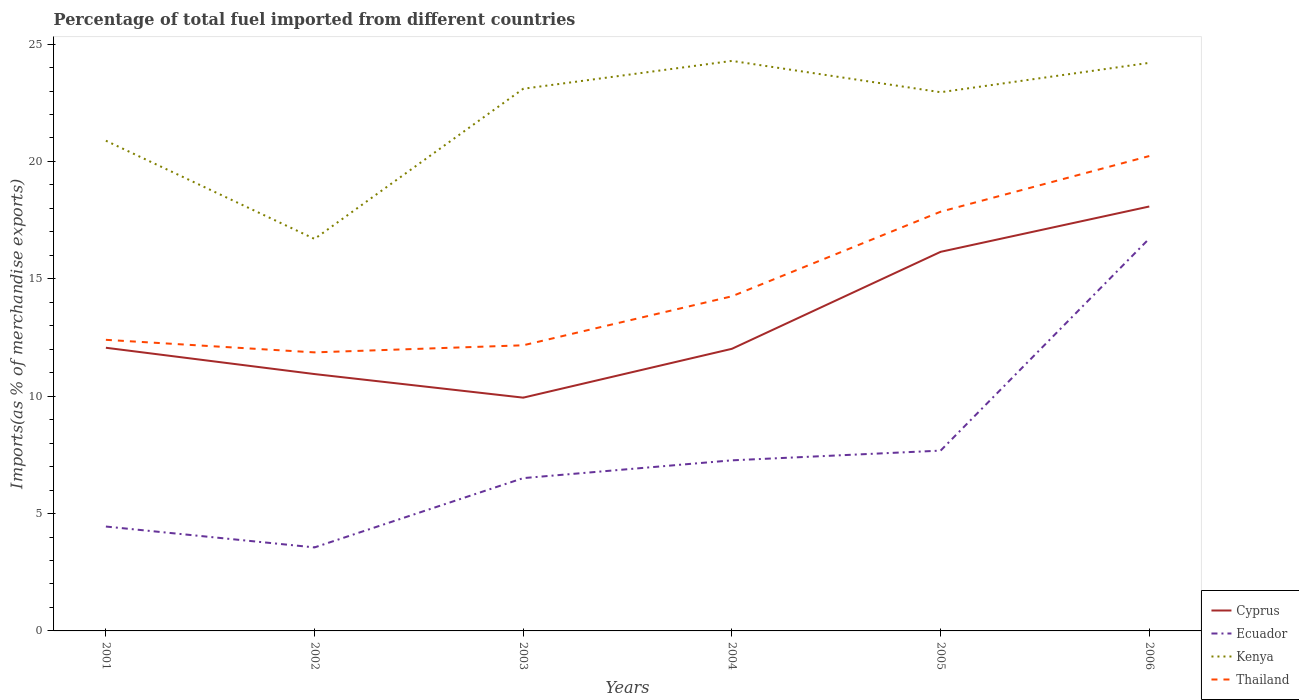How many different coloured lines are there?
Make the answer very short. 4. Across all years, what is the maximum percentage of imports to different countries in Thailand?
Make the answer very short. 11.87. In which year was the percentage of imports to different countries in Kenya maximum?
Provide a succinct answer. 2002. What is the total percentage of imports to different countries in Cyprus in the graph?
Offer a terse response. -8.14. What is the difference between the highest and the second highest percentage of imports to different countries in Kenya?
Give a very brief answer. 7.58. Is the percentage of imports to different countries in Cyprus strictly greater than the percentage of imports to different countries in Thailand over the years?
Offer a terse response. Yes. How many years are there in the graph?
Offer a terse response. 6. What is the difference between two consecutive major ticks on the Y-axis?
Provide a succinct answer. 5. Does the graph contain grids?
Make the answer very short. No. Where does the legend appear in the graph?
Offer a terse response. Bottom right. How many legend labels are there?
Your response must be concise. 4. How are the legend labels stacked?
Offer a terse response. Vertical. What is the title of the graph?
Offer a terse response. Percentage of total fuel imported from different countries. Does "North America" appear as one of the legend labels in the graph?
Give a very brief answer. No. What is the label or title of the Y-axis?
Provide a succinct answer. Imports(as % of merchandise exports). What is the Imports(as % of merchandise exports) in Cyprus in 2001?
Provide a succinct answer. 12.06. What is the Imports(as % of merchandise exports) in Ecuador in 2001?
Ensure brevity in your answer.  4.45. What is the Imports(as % of merchandise exports) of Kenya in 2001?
Your answer should be compact. 20.88. What is the Imports(as % of merchandise exports) in Thailand in 2001?
Your answer should be very brief. 12.4. What is the Imports(as % of merchandise exports) of Cyprus in 2002?
Provide a short and direct response. 10.94. What is the Imports(as % of merchandise exports) of Ecuador in 2002?
Ensure brevity in your answer.  3.56. What is the Imports(as % of merchandise exports) in Kenya in 2002?
Your answer should be very brief. 16.7. What is the Imports(as % of merchandise exports) in Thailand in 2002?
Provide a short and direct response. 11.87. What is the Imports(as % of merchandise exports) of Cyprus in 2003?
Offer a terse response. 9.94. What is the Imports(as % of merchandise exports) in Ecuador in 2003?
Provide a succinct answer. 6.51. What is the Imports(as % of merchandise exports) in Kenya in 2003?
Provide a succinct answer. 23.1. What is the Imports(as % of merchandise exports) of Thailand in 2003?
Your response must be concise. 12.17. What is the Imports(as % of merchandise exports) of Cyprus in 2004?
Provide a short and direct response. 12.02. What is the Imports(as % of merchandise exports) of Ecuador in 2004?
Provide a succinct answer. 7.27. What is the Imports(as % of merchandise exports) of Kenya in 2004?
Ensure brevity in your answer.  24.28. What is the Imports(as % of merchandise exports) of Thailand in 2004?
Give a very brief answer. 14.26. What is the Imports(as % of merchandise exports) of Cyprus in 2005?
Provide a short and direct response. 16.15. What is the Imports(as % of merchandise exports) in Ecuador in 2005?
Offer a very short reply. 7.68. What is the Imports(as % of merchandise exports) of Kenya in 2005?
Ensure brevity in your answer.  22.95. What is the Imports(as % of merchandise exports) of Thailand in 2005?
Your response must be concise. 17.86. What is the Imports(as % of merchandise exports) in Cyprus in 2006?
Keep it short and to the point. 18.08. What is the Imports(as % of merchandise exports) of Ecuador in 2006?
Offer a terse response. 16.71. What is the Imports(as % of merchandise exports) of Kenya in 2006?
Offer a terse response. 24.2. What is the Imports(as % of merchandise exports) in Thailand in 2006?
Provide a short and direct response. 20.23. Across all years, what is the maximum Imports(as % of merchandise exports) of Cyprus?
Your answer should be very brief. 18.08. Across all years, what is the maximum Imports(as % of merchandise exports) in Ecuador?
Offer a very short reply. 16.71. Across all years, what is the maximum Imports(as % of merchandise exports) in Kenya?
Give a very brief answer. 24.28. Across all years, what is the maximum Imports(as % of merchandise exports) of Thailand?
Provide a short and direct response. 20.23. Across all years, what is the minimum Imports(as % of merchandise exports) in Cyprus?
Offer a very short reply. 9.94. Across all years, what is the minimum Imports(as % of merchandise exports) of Ecuador?
Make the answer very short. 3.56. Across all years, what is the minimum Imports(as % of merchandise exports) of Kenya?
Your response must be concise. 16.7. Across all years, what is the minimum Imports(as % of merchandise exports) in Thailand?
Provide a short and direct response. 11.87. What is the total Imports(as % of merchandise exports) of Cyprus in the graph?
Give a very brief answer. 79.19. What is the total Imports(as % of merchandise exports) in Ecuador in the graph?
Your response must be concise. 46.18. What is the total Imports(as % of merchandise exports) in Kenya in the graph?
Provide a succinct answer. 132.11. What is the total Imports(as % of merchandise exports) of Thailand in the graph?
Provide a short and direct response. 88.78. What is the difference between the Imports(as % of merchandise exports) in Cyprus in 2001 and that in 2002?
Make the answer very short. 1.12. What is the difference between the Imports(as % of merchandise exports) in Ecuador in 2001 and that in 2002?
Make the answer very short. 0.89. What is the difference between the Imports(as % of merchandise exports) in Kenya in 2001 and that in 2002?
Your response must be concise. 4.18. What is the difference between the Imports(as % of merchandise exports) in Thailand in 2001 and that in 2002?
Provide a succinct answer. 0.53. What is the difference between the Imports(as % of merchandise exports) of Cyprus in 2001 and that in 2003?
Offer a terse response. 2.13. What is the difference between the Imports(as % of merchandise exports) in Ecuador in 2001 and that in 2003?
Make the answer very short. -2.06. What is the difference between the Imports(as % of merchandise exports) in Kenya in 2001 and that in 2003?
Your answer should be compact. -2.21. What is the difference between the Imports(as % of merchandise exports) in Thailand in 2001 and that in 2003?
Your answer should be very brief. 0.23. What is the difference between the Imports(as % of merchandise exports) in Cyprus in 2001 and that in 2004?
Offer a terse response. 0.04. What is the difference between the Imports(as % of merchandise exports) in Ecuador in 2001 and that in 2004?
Offer a terse response. -2.82. What is the difference between the Imports(as % of merchandise exports) in Kenya in 2001 and that in 2004?
Provide a short and direct response. -3.4. What is the difference between the Imports(as % of merchandise exports) in Thailand in 2001 and that in 2004?
Provide a short and direct response. -1.85. What is the difference between the Imports(as % of merchandise exports) of Cyprus in 2001 and that in 2005?
Give a very brief answer. -4.09. What is the difference between the Imports(as % of merchandise exports) of Ecuador in 2001 and that in 2005?
Your response must be concise. -3.23. What is the difference between the Imports(as % of merchandise exports) in Kenya in 2001 and that in 2005?
Keep it short and to the point. -2.07. What is the difference between the Imports(as % of merchandise exports) of Thailand in 2001 and that in 2005?
Provide a short and direct response. -5.46. What is the difference between the Imports(as % of merchandise exports) in Cyprus in 2001 and that in 2006?
Your answer should be compact. -6.02. What is the difference between the Imports(as % of merchandise exports) in Ecuador in 2001 and that in 2006?
Your response must be concise. -12.27. What is the difference between the Imports(as % of merchandise exports) of Kenya in 2001 and that in 2006?
Your answer should be compact. -3.32. What is the difference between the Imports(as % of merchandise exports) of Thailand in 2001 and that in 2006?
Provide a short and direct response. -7.83. What is the difference between the Imports(as % of merchandise exports) in Ecuador in 2002 and that in 2003?
Provide a succinct answer. -2.95. What is the difference between the Imports(as % of merchandise exports) of Kenya in 2002 and that in 2003?
Make the answer very short. -6.4. What is the difference between the Imports(as % of merchandise exports) of Thailand in 2002 and that in 2003?
Make the answer very short. -0.3. What is the difference between the Imports(as % of merchandise exports) of Cyprus in 2002 and that in 2004?
Ensure brevity in your answer.  -1.08. What is the difference between the Imports(as % of merchandise exports) in Ecuador in 2002 and that in 2004?
Make the answer very short. -3.71. What is the difference between the Imports(as % of merchandise exports) in Kenya in 2002 and that in 2004?
Offer a terse response. -7.58. What is the difference between the Imports(as % of merchandise exports) in Thailand in 2002 and that in 2004?
Your response must be concise. -2.39. What is the difference between the Imports(as % of merchandise exports) in Cyprus in 2002 and that in 2005?
Offer a terse response. -5.21. What is the difference between the Imports(as % of merchandise exports) of Ecuador in 2002 and that in 2005?
Your answer should be compact. -4.12. What is the difference between the Imports(as % of merchandise exports) of Kenya in 2002 and that in 2005?
Your answer should be very brief. -6.25. What is the difference between the Imports(as % of merchandise exports) of Thailand in 2002 and that in 2005?
Keep it short and to the point. -5.99. What is the difference between the Imports(as % of merchandise exports) of Cyprus in 2002 and that in 2006?
Give a very brief answer. -7.14. What is the difference between the Imports(as % of merchandise exports) in Ecuador in 2002 and that in 2006?
Offer a very short reply. -13.16. What is the difference between the Imports(as % of merchandise exports) in Kenya in 2002 and that in 2006?
Offer a very short reply. -7.5. What is the difference between the Imports(as % of merchandise exports) in Thailand in 2002 and that in 2006?
Offer a very short reply. -8.36. What is the difference between the Imports(as % of merchandise exports) in Cyprus in 2003 and that in 2004?
Provide a short and direct response. -2.08. What is the difference between the Imports(as % of merchandise exports) in Ecuador in 2003 and that in 2004?
Provide a short and direct response. -0.76. What is the difference between the Imports(as % of merchandise exports) of Kenya in 2003 and that in 2004?
Keep it short and to the point. -1.19. What is the difference between the Imports(as % of merchandise exports) of Thailand in 2003 and that in 2004?
Your answer should be compact. -2.09. What is the difference between the Imports(as % of merchandise exports) in Cyprus in 2003 and that in 2005?
Ensure brevity in your answer.  -6.21. What is the difference between the Imports(as % of merchandise exports) of Ecuador in 2003 and that in 2005?
Offer a very short reply. -1.17. What is the difference between the Imports(as % of merchandise exports) in Kenya in 2003 and that in 2005?
Keep it short and to the point. 0.15. What is the difference between the Imports(as % of merchandise exports) of Thailand in 2003 and that in 2005?
Your answer should be very brief. -5.69. What is the difference between the Imports(as % of merchandise exports) of Cyprus in 2003 and that in 2006?
Offer a very short reply. -8.14. What is the difference between the Imports(as % of merchandise exports) of Ecuador in 2003 and that in 2006?
Keep it short and to the point. -10.2. What is the difference between the Imports(as % of merchandise exports) of Kenya in 2003 and that in 2006?
Your answer should be compact. -1.1. What is the difference between the Imports(as % of merchandise exports) of Thailand in 2003 and that in 2006?
Make the answer very short. -8.06. What is the difference between the Imports(as % of merchandise exports) of Cyprus in 2004 and that in 2005?
Your response must be concise. -4.13. What is the difference between the Imports(as % of merchandise exports) of Ecuador in 2004 and that in 2005?
Keep it short and to the point. -0.41. What is the difference between the Imports(as % of merchandise exports) in Kenya in 2004 and that in 2005?
Offer a very short reply. 1.33. What is the difference between the Imports(as % of merchandise exports) in Thailand in 2004 and that in 2005?
Provide a short and direct response. -3.6. What is the difference between the Imports(as % of merchandise exports) of Cyprus in 2004 and that in 2006?
Give a very brief answer. -6.06. What is the difference between the Imports(as % of merchandise exports) of Ecuador in 2004 and that in 2006?
Keep it short and to the point. -9.45. What is the difference between the Imports(as % of merchandise exports) of Kenya in 2004 and that in 2006?
Your answer should be compact. 0.08. What is the difference between the Imports(as % of merchandise exports) in Thailand in 2004 and that in 2006?
Provide a short and direct response. -5.97. What is the difference between the Imports(as % of merchandise exports) of Cyprus in 2005 and that in 2006?
Provide a short and direct response. -1.93. What is the difference between the Imports(as % of merchandise exports) in Ecuador in 2005 and that in 2006?
Provide a succinct answer. -9.03. What is the difference between the Imports(as % of merchandise exports) in Kenya in 2005 and that in 2006?
Offer a terse response. -1.25. What is the difference between the Imports(as % of merchandise exports) of Thailand in 2005 and that in 2006?
Make the answer very short. -2.37. What is the difference between the Imports(as % of merchandise exports) of Cyprus in 2001 and the Imports(as % of merchandise exports) of Ecuador in 2002?
Make the answer very short. 8.51. What is the difference between the Imports(as % of merchandise exports) in Cyprus in 2001 and the Imports(as % of merchandise exports) in Kenya in 2002?
Your answer should be compact. -4.64. What is the difference between the Imports(as % of merchandise exports) of Cyprus in 2001 and the Imports(as % of merchandise exports) of Thailand in 2002?
Keep it short and to the point. 0.2. What is the difference between the Imports(as % of merchandise exports) in Ecuador in 2001 and the Imports(as % of merchandise exports) in Kenya in 2002?
Offer a very short reply. -12.25. What is the difference between the Imports(as % of merchandise exports) in Ecuador in 2001 and the Imports(as % of merchandise exports) in Thailand in 2002?
Make the answer very short. -7.42. What is the difference between the Imports(as % of merchandise exports) of Kenya in 2001 and the Imports(as % of merchandise exports) of Thailand in 2002?
Provide a succinct answer. 9.02. What is the difference between the Imports(as % of merchandise exports) in Cyprus in 2001 and the Imports(as % of merchandise exports) in Ecuador in 2003?
Make the answer very short. 5.55. What is the difference between the Imports(as % of merchandise exports) in Cyprus in 2001 and the Imports(as % of merchandise exports) in Kenya in 2003?
Offer a terse response. -11.03. What is the difference between the Imports(as % of merchandise exports) in Cyprus in 2001 and the Imports(as % of merchandise exports) in Thailand in 2003?
Your answer should be compact. -0.11. What is the difference between the Imports(as % of merchandise exports) in Ecuador in 2001 and the Imports(as % of merchandise exports) in Kenya in 2003?
Your answer should be compact. -18.65. What is the difference between the Imports(as % of merchandise exports) of Ecuador in 2001 and the Imports(as % of merchandise exports) of Thailand in 2003?
Your response must be concise. -7.72. What is the difference between the Imports(as % of merchandise exports) in Kenya in 2001 and the Imports(as % of merchandise exports) in Thailand in 2003?
Provide a succinct answer. 8.71. What is the difference between the Imports(as % of merchandise exports) in Cyprus in 2001 and the Imports(as % of merchandise exports) in Ecuador in 2004?
Your answer should be compact. 4.8. What is the difference between the Imports(as % of merchandise exports) of Cyprus in 2001 and the Imports(as % of merchandise exports) of Kenya in 2004?
Ensure brevity in your answer.  -12.22. What is the difference between the Imports(as % of merchandise exports) in Cyprus in 2001 and the Imports(as % of merchandise exports) in Thailand in 2004?
Your answer should be very brief. -2.19. What is the difference between the Imports(as % of merchandise exports) of Ecuador in 2001 and the Imports(as % of merchandise exports) of Kenya in 2004?
Keep it short and to the point. -19.84. What is the difference between the Imports(as % of merchandise exports) in Ecuador in 2001 and the Imports(as % of merchandise exports) in Thailand in 2004?
Provide a succinct answer. -9.81. What is the difference between the Imports(as % of merchandise exports) in Kenya in 2001 and the Imports(as % of merchandise exports) in Thailand in 2004?
Your response must be concise. 6.63. What is the difference between the Imports(as % of merchandise exports) of Cyprus in 2001 and the Imports(as % of merchandise exports) of Ecuador in 2005?
Offer a terse response. 4.38. What is the difference between the Imports(as % of merchandise exports) of Cyprus in 2001 and the Imports(as % of merchandise exports) of Kenya in 2005?
Offer a very short reply. -10.89. What is the difference between the Imports(as % of merchandise exports) of Cyprus in 2001 and the Imports(as % of merchandise exports) of Thailand in 2005?
Make the answer very short. -5.8. What is the difference between the Imports(as % of merchandise exports) in Ecuador in 2001 and the Imports(as % of merchandise exports) in Kenya in 2005?
Provide a succinct answer. -18.5. What is the difference between the Imports(as % of merchandise exports) of Ecuador in 2001 and the Imports(as % of merchandise exports) of Thailand in 2005?
Your answer should be very brief. -13.41. What is the difference between the Imports(as % of merchandise exports) in Kenya in 2001 and the Imports(as % of merchandise exports) in Thailand in 2005?
Your answer should be very brief. 3.02. What is the difference between the Imports(as % of merchandise exports) in Cyprus in 2001 and the Imports(as % of merchandise exports) in Ecuador in 2006?
Provide a short and direct response. -4.65. What is the difference between the Imports(as % of merchandise exports) of Cyprus in 2001 and the Imports(as % of merchandise exports) of Kenya in 2006?
Make the answer very short. -12.14. What is the difference between the Imports(as % of merchandise exports) of Cyprus in 2001 and the Imports(as % of merchandise exports) of Thailand in 2006?
Offer a very short reply. -8.17. What is the difference between the Imports(as % of merchandise exports) of Ecuador in 2001 and the Imports(as % of merchandise exports) of Kenya in 2006?
Keep it short and to the point. -19.75. What is the difference between the Imports(as % of merchandise exports) in Ecuador in 2001 and the Imports(as % of merchandise exports) in Thailand in 2006?
Give a very brief answer. -15.78. What is the difference between the Imports(as % of merchandise exports) of Kenya in 2001 and the Imports(as % of merchandise exports) of Thailand in 2006?
Ensure brevity in your answer.  0.65. What is the difference between the Imports(as % of merchandise exports) in Cyprus in 2002 and the Imports(as % of merchandise exports) in Ecuador in 2003?
Your answer should be compact. 4.43. What is the difference between the Imports(as % of merchandise exports) of Cyprus in 2002 and the Imports(as % of merchandise exports) of Kenya in 2003?
Your response must be concise. -12.15. What is the difference between the Imports(as % of merchandise exports) in Cyprus in 2002 and the Imports(as % of merchandise exports) in Thailand in 2003?
Your response must be concise. -1.23. What is the difference between the Imports(as % of merchandise exports) in Ecuador in 2002 and the Imports(as % of merchandise exports) in Kenya in 2003?
Offer a terse response. -19.54. What is the difference between the Imports(as % of merchandise exports) in Ecuador in 2002 and the Imports(as % of merchandise exports) in Thailand in 2003?
Ensure brevity in your answer.  -8.61. What is the difference between the Imports(as % of merchandise exports) of Kenya in 2002 and the Imports(as % of merchandise exports) of Thailand in 2003?
Make the answer very short. 4.53. What is the difference between the Imports(as % of merchandise exports) of Cyprus in 2002 and the Imports(as % of merchandise exports) of Ecuador in 2004?
Provide a short and direct response. 3.68. What is the difference between the Imports(as % of merchandise exports) of Cyprus in 2002 and the Imports(as % of merchandise exports) of Kenya in 2004?
Your response must be concise. -13.34. What is the difference between the Imports(as % of merchandise exports) in Cyprus in 2002 and the Imports(as % of merchandise exports) in Thailand in 2004?
Make the answer very short. -3.31. What is the difference between the Imports(as % of merchandise exports) in Ecuador in 2002 and the Imports(as % of merchandise exports) in Kenya in 2004?
Your response must be concise. -20.73. What is the difference between the Imports(as % of merchandise exports) of Ecuador in 2002 and the Imports(as % of merchandise exports) of Thailand in 2004?
Give a very brief answer. -10.7. What is the difference between the Imports(as % of merchandise exports) of Kenya in 2002 and the Imports(as % of merchandise exports) of Thailand in 2004?
Provide a succinct answer. 2.44. What is the difference between the Imports(as % of merchandise exports) of Cyprus in 2002 and the Imports(as % of merchandise exports) of Ecuador in 2005?
Offer a very short reply. 3.26. What is the difference between the Imports(as % of merchandise exports) of Cyprus in 2002 and the Imports(as % of merchandise exports) of Kenya in 2005?
Ensure brevity in your answer.  -12.01. What is the difference between the Imports(as % of merchandise exports) of Cyprus in 2002 and the Imports(as % of merchandise exports) of Thailand in 2005?
Your answer should be very brief. -6.92. What is the difference between the Imports(as % of merchandise exports) in Ecuador in 2002 and the Imports(as % of merchandise exports) in Kenya in 2005?
Your response must be concise. -19.39. What is the difference between the Imports(as % of merchandise exports) in Ecuador in 2002 and the Imports(as % of merchandise exports) in Thailand in 2005?
Ensure brevity in your answer.  -14.3. What is the difference between the Imports(as % of merchandise exports) of Kenya in 2002 and the Imports(as % of merchandise exports) of Thailand in 2005?
Give a very brief answer. -1.16. What is the difference between the Imports(as % of merchandise exports) of Cyprus in 2002 and the Imports(as % of merchandise exports) of Ecuador in 2006?
Keep it short and to the point. -5.77. What is the difference between the Imports(as % of merchandise exports) in Cyprus in 2002 and the Imports(as % of merchandise exports) in Kenya in 2006?
Provide a short and direct response. -13.26. What is the difference between the Imports(as % of merchandise exports) in Cyprus in 2002 and the Imports(as % of merchandise exports) in Thailand in 2006?
Offer a terse response. -9.29. What is the difference between the Imports(as % of merchandise exports) in Ecuador in 2002 and the Imports(as % of merchandise exports) in Kenya in 2006?
Your answer should be very brief. -20.64. What is the difference between the Imports(as % of merchandise exports) in Ecuador in 2002 and the Imports(as % of merchandise exports) in Thailand in 2006?
Keep it short and to the point. -16.67. What is the difference between the Imports(as % of merchandise exports) in Kenya in 2002 and the Imports(as % of merchandise exports) in Thailand in 2006?
Offer a very short reply. -3.53. What is the difference between the Imports(as % of merchandise exports) of Cyprus in 2003 and the Imports(as % of merchandise exports) of Ecuador in 2004?
Your response must be concise. 2.67. What is the difference between the Imports(as % of merchandise exports) of Cyprus in 2003 and the Imports(as % of merchandise exports) of Kenya in 2004?
Offer a very short reply. -14.35. What is the difference between the Imports(as % of merchandise exports) in Cyprus in 2003 and the Imports(as % of merchandise exports) in Thailand in 2004?
Your answer should be very brief. -4.32. What is the difference between the Imports(as % of merchandise exports) of Ecuador in 2003 and the Imports(as % of merchandise exports) of Kenya in 2004?
Provide a succinct answer. -17.77. What is the difference between the Imports(as % of merchandise exports) of Ecuador in 2003 and the Imports(as % of merchandise exports) of Thailand in 2004?
Provide a short and direct response. -7.75. What is the difference between the Imports(as % of merchandise exports) in Kenya in 2003 and the Imports(as % of merchandise exports) in Thailand in 2004?
Your answer should be very brief. 8.84. What is the difference between the Imports(as % of merchandise exports) in Cyprus in 2003 and the Imports(as % of merchandise exports) in Ecuador in 2005?
Your response must be concise. 2.26. What is the difference between the Imports(as % of merchandise exports) of Cyprus in 2003 and the Imports(as % of merchandise exports) of Kenya in 2005?
Give a very brief answer. -13.01. What is the difference between the Imports(as % of merchandise exports) of Cyprus in 2003 and the Imports(as % of merchandise exports) of Thailand in 2005?
Your answer should be compact. -7.92. What is the difference between the Imports(as % of merchandise exports) in Ecuador in 2003 and the Imports(as % of merchandise exports) in Kenya in 2005?
Provide a short and direct response. -16.44. What is the difference between the Imports(as % of merchandise exports) of Ecuador in 2003 and the Imports(as % of merchandise exports) of Thailand in 2005?
Offer a very short reply. -11.35. What is the difference between the Imports(as % of merchandise exports) of Kenya in 2003 and the Imports(as % of merchandise exports) of Thailand in 2005?
Keep it short and to the point. 5.24. What is the difference between the Imports(as % of merchandise exports) of Cyprus in 2003 and the Imports(as % of merchandise exports) of Ecuador in 2006?
Offer a terse response. -6.78. What is the difference between the Imports(as % of merchandise exports) of Cyprus in 2003 and the Imports(as % of merchandise exports) of Kenya in 2006?
Your answer should be compact. -14.26. What is the difference between the Imports(as % of merchandise exports) in Cyprus in 2003 and the Imports(as % of merchandise exports) in Thailand in 2006?
Your answer should be very brief. -10.29. What is the difference between the Imports(as % of merchandise exports) of Ecuador in 2003 and the Imports(as % of merchandise exports) of Kenya in 2006?
Offer a very short reply. -17.69. What is the difference between the Imports(as % of merchandise exports) in Ecuador in 2003 and the Imports(as % of merchandise exports) in Thailand in 2006?
Provide a succinct answer. -13.72. What is the difference between the Imports(as % of merchandise exports) in Kenya in 2003 and the Imports(as % of merchandise exports) in Thailand in 2006?
Provide a succinct answer. 2.87. What is the difference between the Imports(as % of merchandise exports) of Cyprus in 2004 and the Imports(as % of merchandise exports) of Ecuador in 2005?
Offer a very short reply. 4.34. What is the difference between the Imports(as % of merchandise exports) of Cyprus in 2004 and the Imports(as % of merchandise exports) of Kenya in 2005?
Give a very brief answer. -10.93. What is the difference between the Imports(as % of merchandise exports) of Cyprus in 2004 and the Imports(as % of merchandise exports) of Thailand in 2005?
Your answer should be very brief. -5.84. What is the difference between the Imports(as % of merchandise exports) in Ecuador in 2004 and the Imports(as % of merchandise exports) in Kenya in 2005?
Make the answer very short. -15.68. What is the difference between the Imports(as % of merchandise exports) of Ecuador in 2004 and the Imports(as % of merchandise exports) of Thailand in 2005?
Ensure brevity in your answer.  -10.59. What is the difference between the Imports(as % of merchandise exports) of Kenya in 2004 and the Imports(as % of merchandise exports) of Thailand in 2005?
Keep it short and to the point. 6.42. What is the difference between the Imports(as % of merchandise exports) of Cyprus in 2004 and the Imports(as % of merchandise exports) of Ecuador in 2006?
Offer a terse response. -4.7. What is the difference between the Imports(as % of merchandise exports) of Cyprus in 2004 and the Imports(as % of merchandise exports) of Kenya in 2006?
Provide a succinct answer. -12.18. What is the difference between the Imports(as % of merchandise exports) of Cyprus in 2004 and the Imports(as % of merchandise exports) of Thailand in 2006?
Your answer should be very brief. -8.21. What is the difference between the Imports(as % of merchandise exports) of Ecuador in 2004 and the Imports(as % of merchandise exports) of Kenya in 2006?
Give a very brief answer. -16.93. What is the difference between the Imports(as % of merchandise exports) in Ecuador in 2004 and the Imports(as % of merchandise exports) in Thailand in 2006?
Make the answer very short. -12.96. What is the difference between the Imports(as % of merchandise exports) of Kenya in 2004 and the Imports(as % of merchandise exports) of Thailand in 2006?
Provide a succinct answer. 4.05. What is the difference between the Imports(as % of merchandise exports) in Cyprus in 2005 and the Imports(as % of merchandise exports) in Ecuador in 2006?
Your answer should be very brief. -0.56. What is the difference between the Imports(as % of merchandise exports) of Cyprus in 2005 and the Imports(as % of merchandise exports) of Kenya in 2006?
Your answer should be compact. -8.05. What is the difference between the Imports(as % of merchandise exports) in Cyprus in 2005 and the Imports(as % of merchandise exports) in Thailand in 2006?
Your response must be concise. -4.08. What is the difference between the Imports(as % of merchandise exports) in Ecuador in 2005 and the Imports(as % of merchandise exports) in Kenya in 2006?
Make the answer very short. -16.52. What is the difference between the Imports(as % of merchandise exports) of Ecuador in 2005 and the Imports(as % of merchandise exports) of Thailand in 2006?
Your response must be concise. -12.55. What is the difference between the Imports(as % of merchandise exports) in Kenya in 2005 and the Imports(as % of merchandise exports) in Thailand in 2006?
Ensure brevity in your answer.  2.72. What is the average Imports(as % of merchandise exports) of Cyprus per year?
Ensure brevity in your answer.  13.2. What is the average Imports(as % of merchandise exports) of Ecuador per year?
Provide a succinct answer. 7.7. What is the average Imports(as % of merchandise exports) of Kenya per year?
Offer a terse response. 22.02. What is the average Imports(as % of merchandise exports) in Thailand per year?
Ensure brevity in your answer.  14.8. In the year 2001, what is the difference between the Imports(as % of merchandise exports) in Cyprus and Imports(as % of merchandise exports) in Ecuador?
Provide a short and direct response. 7.62. In the year 2001, what is the difference between the Imports(as % of merchandise exports) in Cyprus and Imports(as % of merchandise exports) in Kenya?
Provide a short and direct response. -8.82. In the year 2001, what is the difference between the Imports(as % of merchandise exports) of Cyprus and Imports(as % of merchandise exports) of Thailand?
Make the answer very short. -0.34. In the year 2001, what is the difference between the Imports(as % of merchandise exports) in Ecuador and Imports(as % of merchandise exports) in Kenya?
Offer a terse response. -16.44. In the year 2001, what is the difference between the Imports(as % of merchandise exports) of Ecuador and Imports(as % of merchandise exports) of Thailand?
Your answer should be compact. -7.95. In the year 2001, what is the difference between the Imports(as % of merchandise exports) of Kenya and Imports(as % of merchandise exports) of Thailand?
Provide a succinct answer. 8.48. In the year 2002, what is the difference between the Imports(as % of merchandise exports) in Cyprus and Imports(as % of merchandise exports) in Ecuador?
Your answer should be very brief. 7.38. In the year 2002, what is the difference between the Imports(as % of merchandise exports) of Cyprus and Imports(as % of merchandise exports) of Kenya?
Provide a short and direct response. -5.76. In the year 2002, what is the difference between the Imports(as % of merchandise exports) in Cyprus and Imports(as % of merchandise exports) in Thailand?
Keep it short and to the point. -0.92. In the year 2002, what is the difference between the Imports(as % of merchandise exports) of Ecuador and Imports(as % of merchandise exports) of Kenya?
Offer a terse response. -13.14. In the year 2002, what is the difference between the Imports(as % of merchandise exports) in Ecuador and Imports(as % of merchandise exports) in Thailand?
Make the answer very short. -8.31. In the year 2002, what is the difference between the Imports(as % of merchandise exports) in Kenya and Imports(as % of merchandise exports) in Thailand?
Offer a very short reply. 4.83. In the year 2003, what is the difference between the Imports(as % of merchandise exports) in Cyprus and Imports(as % of merchandise exports) in Ecuador?
Offer a very short reply. 3.43. In the year 2003, what is the difference between the Imports(as % of merchandise exports) of Cyprus and Imports(as % of merchandise exports) of Kenya?
Provide a short and direct response. -13.16. In the year 2003, what is the difference between the Imports(as % of merchandise exports) of Cyprus and Imports(as % of merchandise exports) of Thailand?
Give a very brief answer. -2.23. In the year 2003, what is the difference between the Imports(as % of merchandise exports) in Ecuador and Imports(as % of merchandise exports) in Kenya?
Provide a short and direct response. -16.59. In the year 2003, what is the difference between the Imports(as % of merchandise exports) in Ecuador and Imports(as % of merchandise exports) in Thailand?
Provide a short and direct response. -5.66. In the year 2003, what is the difference between the Imports(as % of merchandise exports) in Kenya and Imports(as % of merchandise exports) in Thailand?
Ensure brevity in your answer.  10.93. In the year 2004, what is the difference between the Imports(as % of merchandise exports) of Cyprus and Imports(as % of merchandise exports) of Ecuador?
Your response must be concise. 4.75. In the year 2004, what is the difference between the Imports(as % of merchandise exports) of Cyprus and Imports(as % of merchandise exports) of Kenya?
Make the answer very short. -12.26. In the year 2004, what is the difference between the Imports(as % of merchandise exports) in Cyprus and Imports(as % of merchandise exports) in Thailand?
Give a very brief answer. -2.24. In the year 2004, what is the difference between the Imports(as % of merchandise exports) of Ecuador and Imports(as % of merchandise exports) of Kenya?
Your answer should be very brief. -17.02. In the year 2004, what is the difference between the Imports(as % of merchandise exports) in Ecuador and Imports(as % of merchandise exports) in Thailand?
Your response must be concise. -6.99. In the year 2004, what is the difference between the Imports(as % of merchandise exports) of Kenya and Imports(as % of merchandise exports) of Thailand?
Your answer should be compact. 10.03. In the year 2005, what is the difference between the Imports(as % of merchandise exports) of Cyprus and Imports(as % of merchandise exports) of Ecuador?
Offer a terse response. 8.47. In the year 2005, what is the difference between the Imports(as % of merchandise exports) in Cyprus and Imports(as % of merchandise exports) in Kenya?
Provide a short and direct response. -6.8. In the year 2005, what is the difference between the Imports(as % of merchandise exports) in Cyprus and Imports(as % of merchandise exports) in Thailand?
Your answer should be very brief. -1.71. In the year 2005, what is the difference between the Imports(as % of merchandise exports) of Ecuador and Imports(as % of merchandise exports) of Kenya?
Ensure brevity in your answer.  -15.27. In the year 2005, what is the difference between the Imports(as % of merchandise exports) of Ecuador and Imports(as % of merchandise exports) of Thailand?
Offer a terse response. -10.18. In the year 2005, what is the difference between the Imports(as % of merchandise exports) of Kenya and Imports(as % of merchandise exports) of Thailand?
Offer a very short reply. 5.09. In the year 2006, what is the difference between the Imports(as % of merchandise exports) of Cyprus and Imports(as % of merchandise exports) of Ecuador?
Provide a succinct answer. 1.37. In the year 2006, what is the difference between the Imports(as % of merchandise exports) in Cyprus and Imports(as % of merchandise exports) in Kenya?
Ensure brevity in your answer.  -6.12. In the year 2006, what is the difference between the Imports(as % of merchandise exports) in Cyprus and Imports(as % of merchandise exports) in Thailand?
Your response must be concise. -2.15. In the year 2006, what is the difference between the Imports(as % of merchandise exports) in Ecuador and Imports(as % of merchandise exports) in Kenya?
Your answer should be very brief. -7.49. In the year 2006, what is the difference between the Imports(as % of merchandise exports) of Ecuador and Imports(as % of merchandise exports) of Thailand?
Provide a short and direct response. -3.52. In the year 2006, what is the difference between the Imports(as % of merchandise exports) in Kenya and Imports(as % of merchandise exports) in Thailand?
Offer a terse response. 3.97. What is the ratio of the Imports(as % of merchandise exports) in Cyprus in 2001 to that in 2002?
Provide a short and direct response. 1.1. What is the ratio of the Imports(as % of merchandise exports) of Kenya in 2001 to that in 2002?
Keep it short and to the point. 1.25. What is the ratio of the Imports(as % of merchandise exports) in Thailand in 2001 to that in 2002?
Your answer should be compact. 1.05. What is the ratio of the Imports(as % of merchandise exports) of Cyprus in 2001 to that in 2003?
Keep it short and to the point. 1.21. What is the ratio of the Imports(as % of merchandise exports) in Ecuador in 2001 to that in 2003?
Give a very brief answer. 0.68. What is the ratio of the Imports(as % of merchandise exports) in Kenya in 2001 to that in 2003?
Provide a succinct answer. 0.9. What is the ratio of the Imports(as % of merchandise exports) of Thailand in 2001 to that in 2003?
Keep it short and to the point. 1.02. What is the ratio of the Imports(as % of merchandise exports) of Cyprus in 2001 to that in 2004?
Make the answer very short. 1. What is the ratio of the Imports(as % of merchandise exports) in Ecuador in 2001 to that in 2004?
Ensure brevity in your answer.  0.61. What is the ratio of the Imports(as % of merchandise exports) in Kenya in 2001 to that in 2004?
Your response must be concise. 0.86. What is the ratio of the Imports(as % of merchandise exports) in Thailand in 2001 to that in 2004?
Your response must be concise. 0.87. What is the ratio of the Imports(as % of merchandise exports) of Cyprus in 2001 to that in 2005?
Your response must be concise. 0.75. What is the ratio of the Imports(as % of merchandise exports) of Ecuador in 2001 to that in 2005?
Give a very brief answer. 0.58. What is the ratio of the Imports(as % of merchandise exports) in Kenya in 2001 to that in 2005?
Make the answer very short. 0.91. What is the ratio of the Imports(as % of merchandise exports) in Thailand in 2001 to that in 2005?
Offer a very short reply. 0.69. What is the ratio of the Imports(as % of merchandise exports) of Cyprus in 2001 to that in 2006?
Provide a succinct answer. 0.67. What is the ratio of the Imports(as % of merchandise exports) in Ecuador in 2001 to that in 2006?
Your response must be concise. 0.27. What is the ratio of the Imports(as % of merchandise exports) in Kenya in 2001 to that in 2006?
Make the answer very short. 0.86. What is the ratio of the Imports(as % of merchandise exports) of Thailand in 2001 to that in 2006?
Provide a short and direct response. 0.61. What is the ratio of the Imports(as % of merchandise exports) of Cyprus in 2002 to that in 2003?
Ensure brevity in your answer.  1.1. What is the ratio of the Imports(as % of merchandise exports) of Ecuador in 2002 to that in 2003?
Offer a very short reply. 0.55. What is the ratio of the Imports(as % of merchandise exports) in Kenya in 2002 to that in 2003?
Your answer should be very brief. 0.72. What is the ratio of the Imports(as % of merchandise exports) in Thailand in 2002 to that in 2003?
Your answer should be very brief. 0.98. What is the ratio of the Imports(as % of merchandise exports) of Cyprus in 2002 to that in 2004?
Make the answer very short. 0.91. What is the ratio of the Imports(as % of merchandise exports) in Ecuador in 2002 to that in 2004?
Ensure brevity in your answer.  0.49. What is the ratio of the Imports(as % of merchandise exports) of Kenya in 2002 to that in 2004?
Give a very brief answer. 0.69. What is the ratio of the Imports(as % of merchandise exports) of Thailand in 2002 to that in 2004?
Make the answer very short. 0.83. What is the ratio of the Imports(as % of merchandise exports) of Cyprus in 2002 to that in 2005?
Offer a very short reply. 0.68. What is the ratio of the Imports(as % of merchandise exports) in Ecuador in 2002 to that in 2005?
Ensure brevity in your answer.  0.46. What is the ratio of the Imports(as % of merchandise exports) in Kenya in 2002 to that in 2005?
Your answer should be compact. 0.73. What is the ratio of the Imports(as % of merchandise exports) of Thailand in 2002 to that in 2005?
Provide a short and direct response. 0.66. What is the ratio of the Imports(as % of merchandise exports) in Cyprus in 2002 to that in 2006?
Make the answer very short. 0.61. What is the ratio of the Imports(as % of merchandise exports) in Ecuador in 2002 to that in 2006?
Make the answer very short. 0.21. What is the ratio of the Imports(as % of merchandise exports) in Kenya in 2002 to that in 2006?
Your answer should be very brief. 0.69. What is the ratio of the Imports(as % of merchandise exports) of Thailand in 2002 to that in 2006?
Keep it short and to the point. 0.59. What is the ratio of the Imports(as % of merchandise exports) of Cyprus in 2003 to that in 2004?
Provide a short and direct response. 0.83. What is the ratio of the Imports(as % of merchandise exports) of Ecuador in 2003 to that in 2004?
Your response must be concise. 0.9. What is the ratio of the Imports(as % of merchandise exports) in Kenya in 2003 to that in 2004?
Ensure brevity in your answer.  0.95. What is the ratio of the Imports(as % of merchandise exports) of Thailand in 2003 to that in 2004?
Ensure brevity in your answer.  0.85. What is the ratio of the Imports(as % of merchandise exports) of Cyprus in 2003 to that in 2005?
Provide a short and direct response. 0.62. What is the ratio of the Imports(as % of merchandise exports) of Ecuador in 2003 to that in 2005?
Offer a terse response. 0.85. What is the ratio of the Imports(as % of merchandise exports) of Kenya in 2003 to that in 2005?
Your answer should be compact. 1.01. What is the ratio of the Imports(as % of merchandise exports) in Thailand in 2003 to that in 2005?
Make the answer very short. 0.68. What is the ratio of the Imports(as % of merchandise exports) in Cyprus in 2003 to that in 2006?
Your answer should be very brief. 0.55. What is the ratio of the Imports(as % of merchandise exports) of Ecuador in 2003 to that in 2006?
Offer a terse response. 0.39. What is the ratio of the Imports(as % of merchandise exports) in Kenya in 2003 to that in 2006?
Keep it short and to the point. 0.95. What is the ratio of the Imports(as % of merchandise exports) in Thailand in 2003 to that in 2006?
Keep it short and to the point. 0.6. What is the ratio of the Imports(as % of merchandise exports) of Cyprus in 2004 to that in 2005?
Provide a short and direct response. 0.74. What is the ratio of the Imports(as % of merchandise exports) of Ecuador in 2004 to that in 2005?
Your answer should be compact. 0.95. What is the ratio of the Imports(as % of merchandise exports) in Kenya in 2004 to that in 2005?
Keep it short and to the point. 1.06. What is the ratio of the Imports(as % of merchandise exports) in Thailand in 2004 to that in 2005?
Provide a succinct answer. 0.8. What is the ratio of the Imports(as % of merchandise exports) of Cyprus in 2004 to that in 2006?
Your answer should be compact. 0.66. What is the ratio of the Imports(as % of merchandise exports) of Ecuador in 2004 to that in 2006?
Ensure brevity in your answer.  0.43. What is the ratio of the Imports(as % of merchandise exports) of Kenya in 2004 to that in 2006?
Provide a short and direct response. 1. What is the ratio of the Imports(as % of merchandise exports) of Thailand in 2004 to that in 2006?
Your answer should be compact. 0.7. What is the ratio of the Imports(as % of merchandise exports) of Cyprus in 2005 to that in 2006?
Provide a short and direct response. 0.89. What is the ratio of the Imports(as % of merchandise exports) of Ecuador in 2005 to that in 2006?
Your response must be concise. 0.46. What is the ratio of the Imports(as % of merchandise exports) of Kenya in 2005 to that in 2006?
Offer a very short reply. 0.95. What is the ratio of the Imports(as % of merchandise exports) in Thailand in 2005 to that in 2006?
Your response must be concise. 0.88. What is the difference between the highest and the second highest Imports(as % of merchandise exports) of Cyprus?
Make the answer very short. 1.93. What is the difference between the highest and the second highest Imports(as % of merchandise exports) of Ecuador?
Give a very brief answer. 9.03. What is the difference between the highest and the second highest Imports(as % of merchandise exports) of Kenya?
Ensure brevity in your answer.  0.08. What is the difference between the highest and the second highest Imports(as % of merchandise exports) in Thailand?
Give a very brief answer. 2.37. What is the difference between the highest and the lowest Imports(as % of merchandise exports) of Cyprus?
Your response must be concise. 8.14. What is the difference between the highest and the lowest Imports(as % of merchandise exports) in Ecuador?
Your answer should be compact. 13.16. What is the difference between the highest and the lowest Imports(as % of merchandise exports) in Kenya?
Offer a very short reply. 7.58. What is the difference between the highest and the lowest Imports(as % of merchandise exports) of Thailand?
Provide a short and direct response. 8.36. 